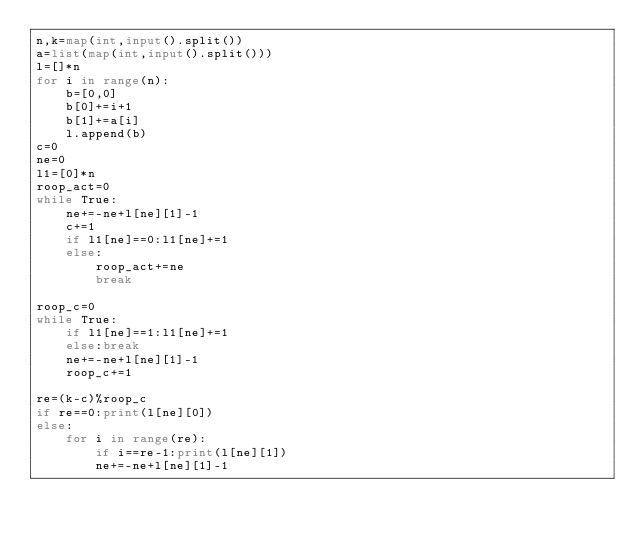<code> <loc_0><loc_0><loc_500><loc_500><_Python_>n,k=map(int,input().split())
a=list(map(int,input().split()))
l=[]*n
for i in range(n):
    b=[0,0]
    b[0]+=i+1
    b[1]+=a[i]
    l.append(b)
c=0
ne=0
l1=[0]*n
roop_act=0
while True:
    ne+=-ne+l[ne][1]-1
    c+=1
    if l1[ne]==0:l1[ne]+=1
    else:
        roop_act+=ne
        break

roop_c=0
while True:
    if l1[ne]==1:l1[ne]+=1
    else:break
    ne+=-ne+l[ne][1]-1
    roop_c+=1

re=(k-c)%roop_c
if re==0:print(l[ne][0])
else:
    for i in range(re):
        if i==re-1:print(l[ne][1])
        ne+=-ne+l[ne][1]-1</code> 